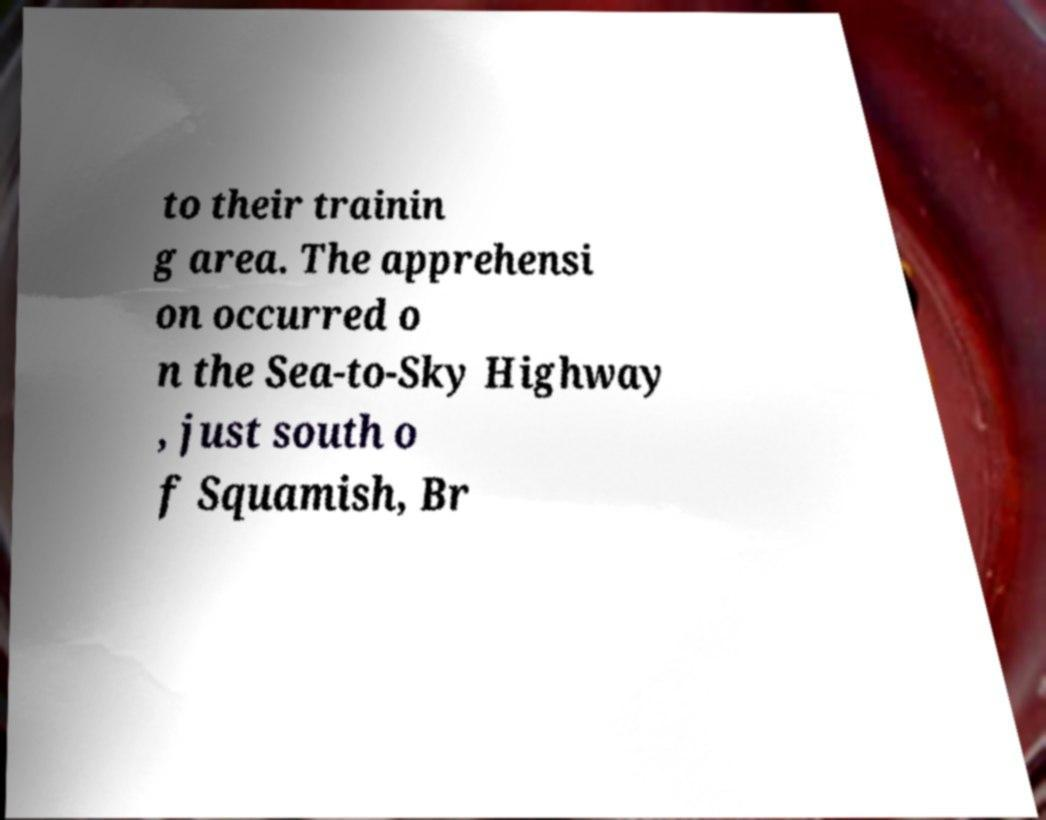I need the written content from this picture converted into text. Can you do that? to their trainin g area. The apprehensi on occurred o n the Sea-to-Sky Highway , just south o f Squamish, Br 